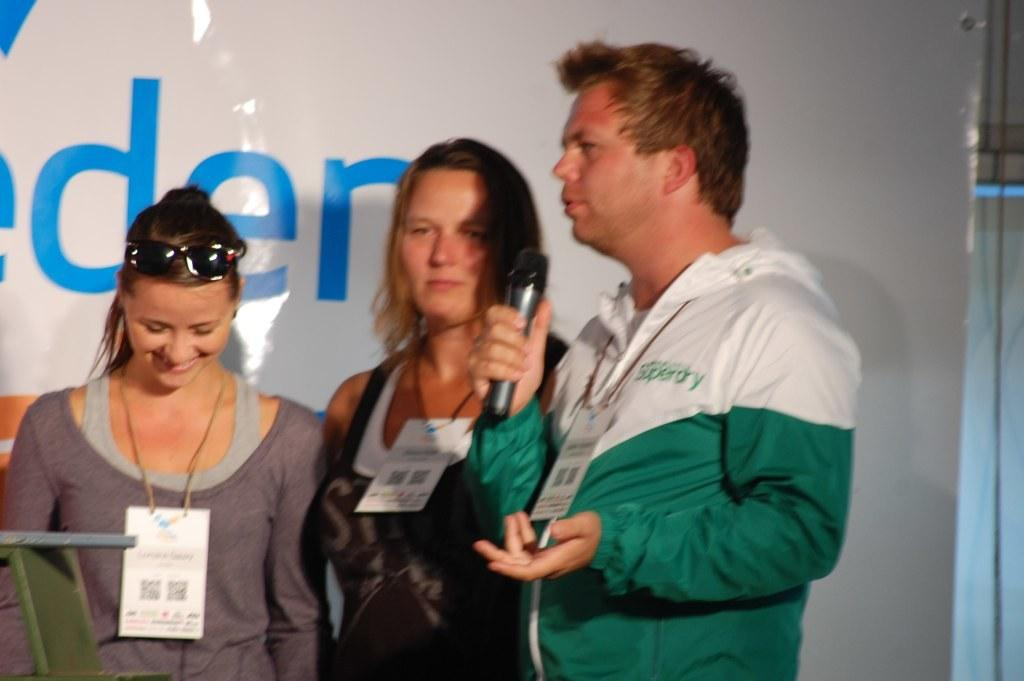How many people are present in the image? There are three people standing in the image. What is the man holding in the image? The man is holding a mic in the image. What can be seen on the wall in the background of the image? There is a white wall with text in the background of the image. Reasoning: Let'g: Let's think step by step in order to produce the conversation. We start by identifying the number of people in the image, which is three. Then, we focus on the man holding the mic, as it is a specific detail that can be observed in the image. Finally, we describe the background, which includes a white wall with text. Each question is designed to elicit a specific detail about the image that is known from the provided facts. Absurd Question/Answer: What type of tub is visible in the image? There is no tub present in the image. What is the tendency of the people in the image? The provided facts do not give any information about the people's tendencies, so we cannot answer this question. What type of advertisement is displayed on the wall in the image? There is no advertisement present in the image; it only shows a white wall with text. What kind of creature is interacting with the people in the image? There is no creature present in the image; it only shows three people and a man holding a mic. 